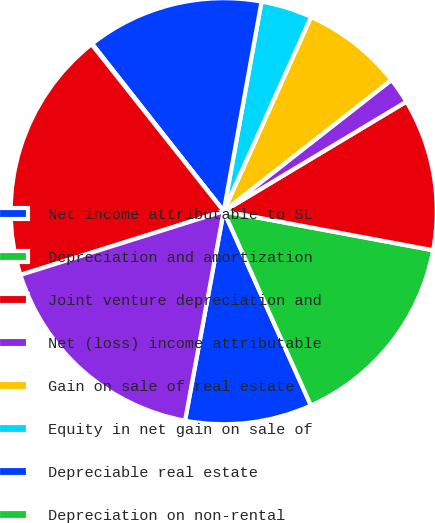Convert chart. <chart><loc_0><loc_0><loc_500><loc_500><pie_chart><fcel>Net income attributable to SL<fcel>Depreciation and amortization<fcel>Joint venture depreciation and<fcel>Net (loss) income attributable<fcel>Gain on sale of real estate<fcel>Equity in net gain on sale of<fcel>Depreciable real estate<fcel>Depreciation on non-rental<fcel>Funds from Operations<fcel>Cash flows provided by<nl><fcel>9.62%<fcel>15.35%<fcel>11.53%<fcel>1.97%<fcel>7.71%<fcel>3.88%<fcel>13.44%<fcel>0.06%<fcel>19.17%<fcel>17.26%<nl></chart> 